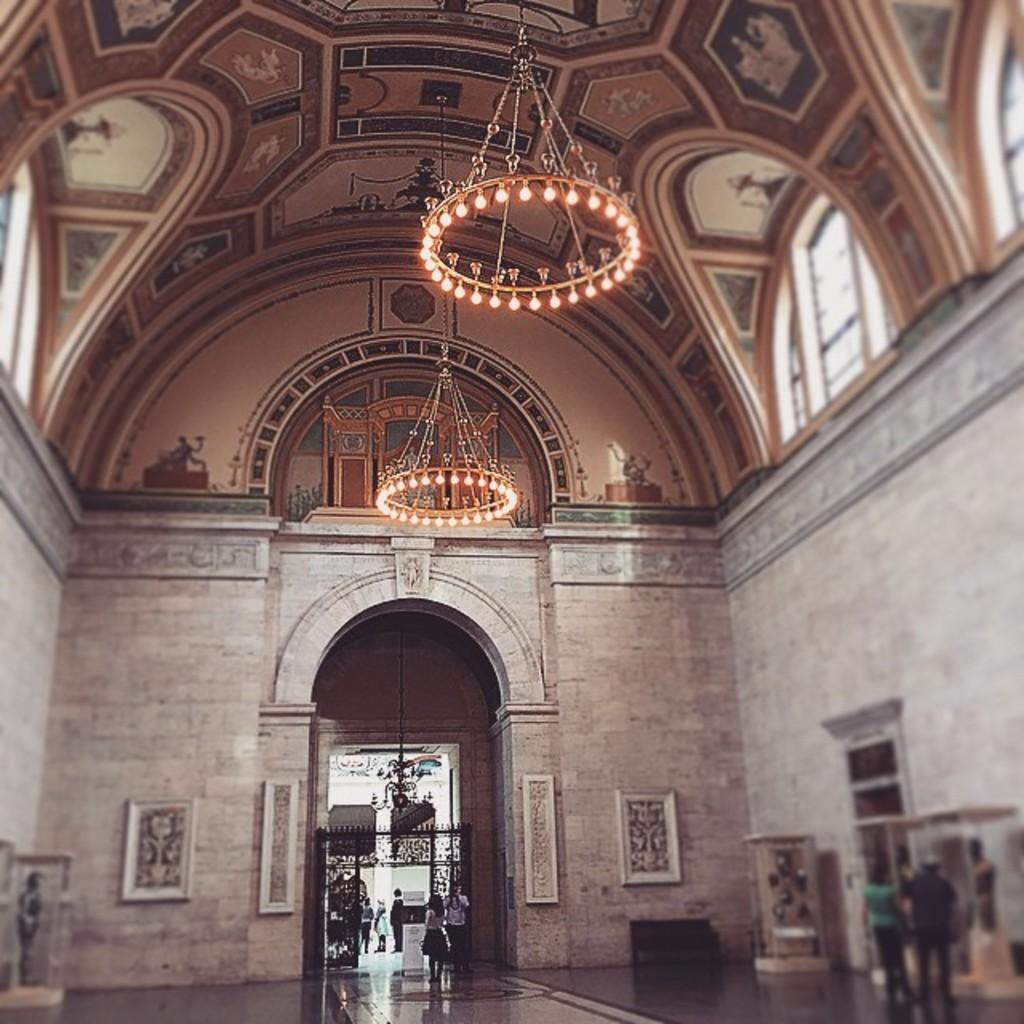In one or two sentences, can you explain what this image depicts? In this picture we can see a monument. On the bottom we can see group of person standing near to the gate. On the bottom right corner we can see two persons standing near to the statues. On the top we can see chandeliers which is hanging to the dome. On the right we can see windows. Here we can see frames and box near to the gate. 